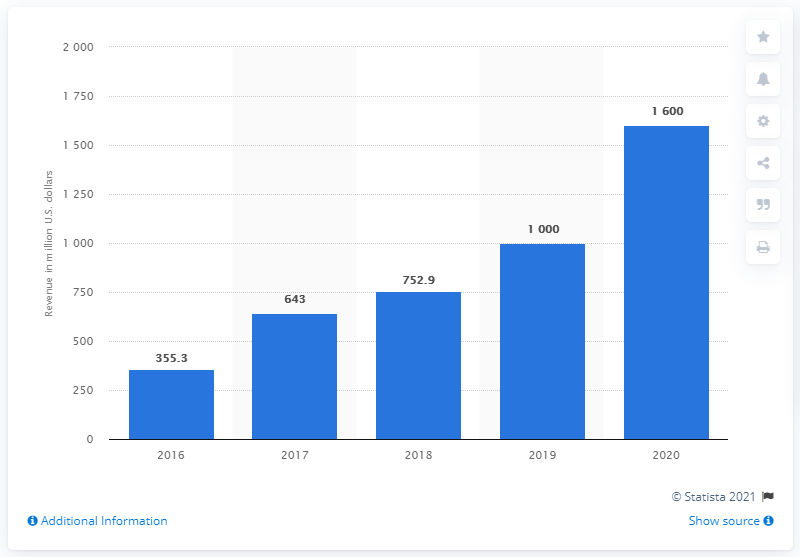What trend can you see in Snapchat's revenue from the years 2016 to 2020? The revenue shows a rising trend from 2016 to 2020, starting from approximately $355.3 million in 2016 and reaching $1,600 million in 2020. Short declines in revenue growth rates can be observed between 2018 and 2019. 